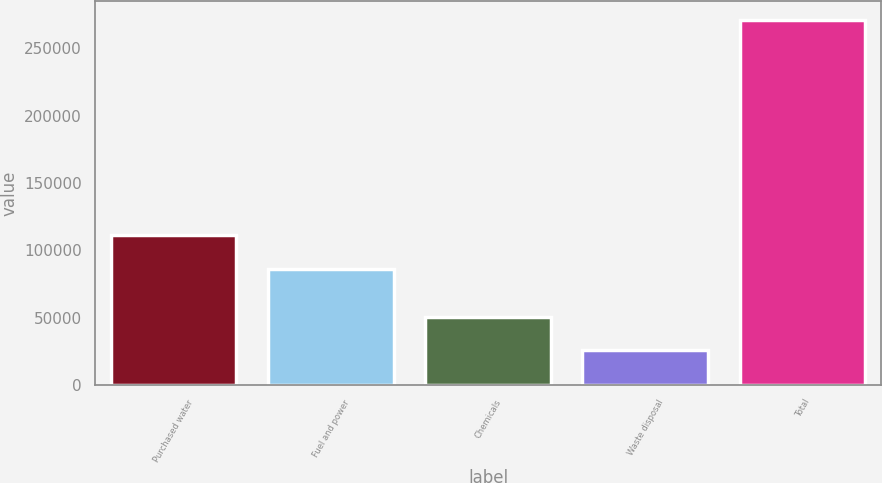Convert chart. <chart><loc_0><loc_0><loc_500><loc_500><bar_chart><fcel>Purchased water<fcel>Fuel and power<fcel>Chemicals<fcel>Waste disposal<fcel>Total<nl><fcel>111119<fcel>86337<fcel>50359.7<fcel>25824<fcel>271181<nl></chart> 